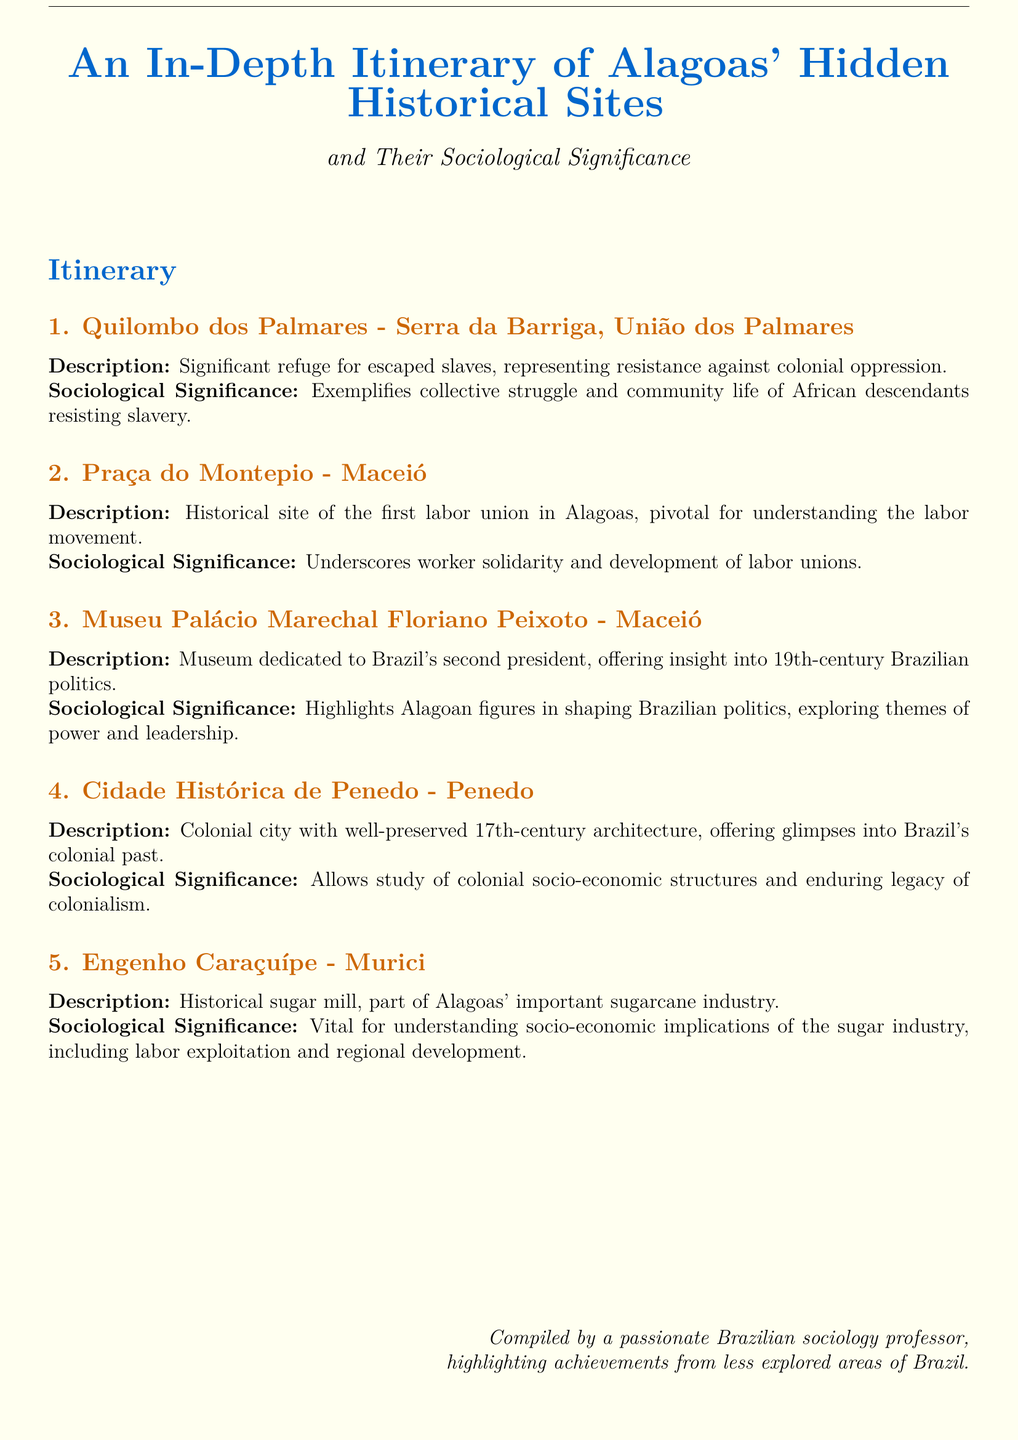What is the first site listed in the itinerary? The first site mentioned in the itinerary is Quilombo dos Palmares.
Answer: Quilombo dos Palmares What significant historical role does Quilombo dos Palmares represent? Quilombo dos Palmares is a significant refuge for escaped slaves, representing resistance against colonial oppression.
Answer: Resistance against colonial oppression How many historical sites are detailed in the itinerary? There are five historical sites detailed in the itinerary.
Answer: Five Which city is home to Museu Palácio Marechal Floriano Peixoto? The city home to Museu Palácio Marechal Floriano Peixoto is Maceió.
Answer: Maceió What sociological aspect does the Praça do Montepio highlight? Praça do Montepio underscores worker solidarity and development of labor unions.
Answer: Worker solidarity What century's architecture can be seen in Cidade Histórica de Penedo? The architecture in Cidade Histórica de Penedo is from the 17th century.
Answer: 17th century What industry does Engenho Caraçuípe relate to? Engenho Caraçuípe relates to the sugarcane industry.
Answer: Sugarcane industry What theme does the Museu Palácio Marechal Floriano Peixoto explore? The museum explores themes of power and leadership in Brazilian politics.
Answer: Power and leadership What is the sociological significance of Quilombo dos Palmares? Quilombo dos Palmares exemplifies collective struggle and community life of African descendants.
Answer: Collective struggle and community life 